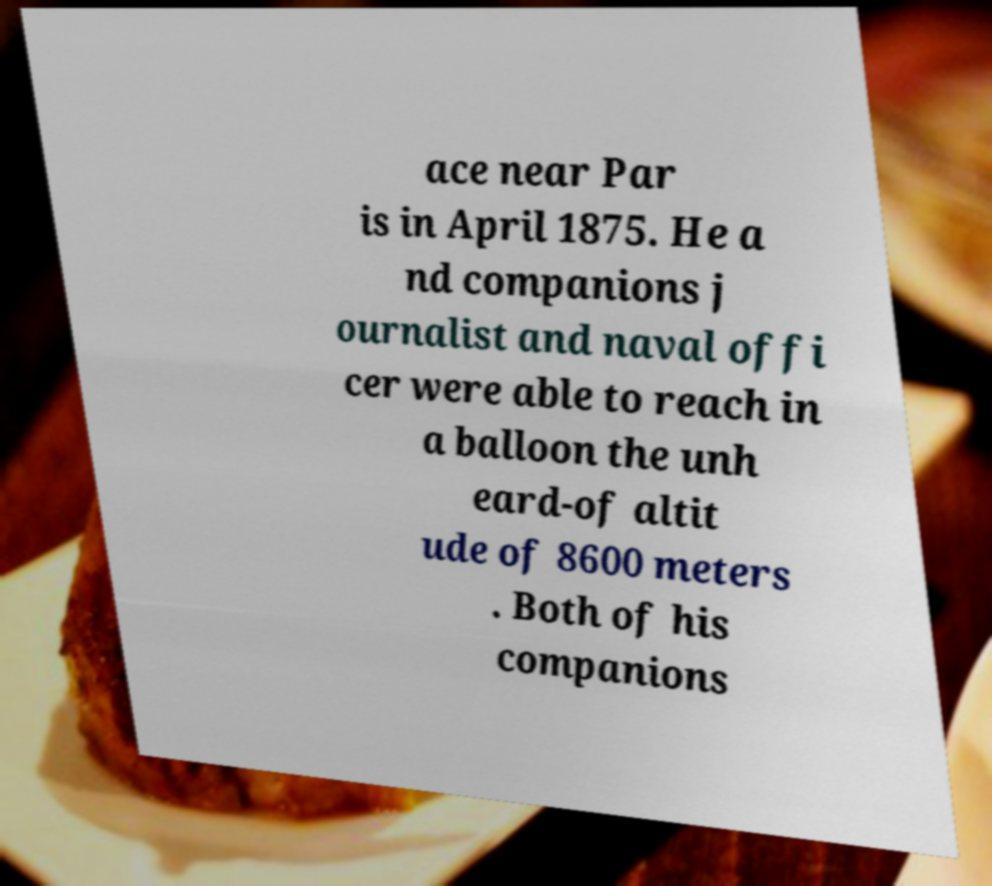Could you extract and type out the text from this image? ace near Par is in April 1875. He a nd companions j ournalist and naval offi cer were able to reach in a balloon the unh eard-of altit ude of 8600 meters . Both of his companions 